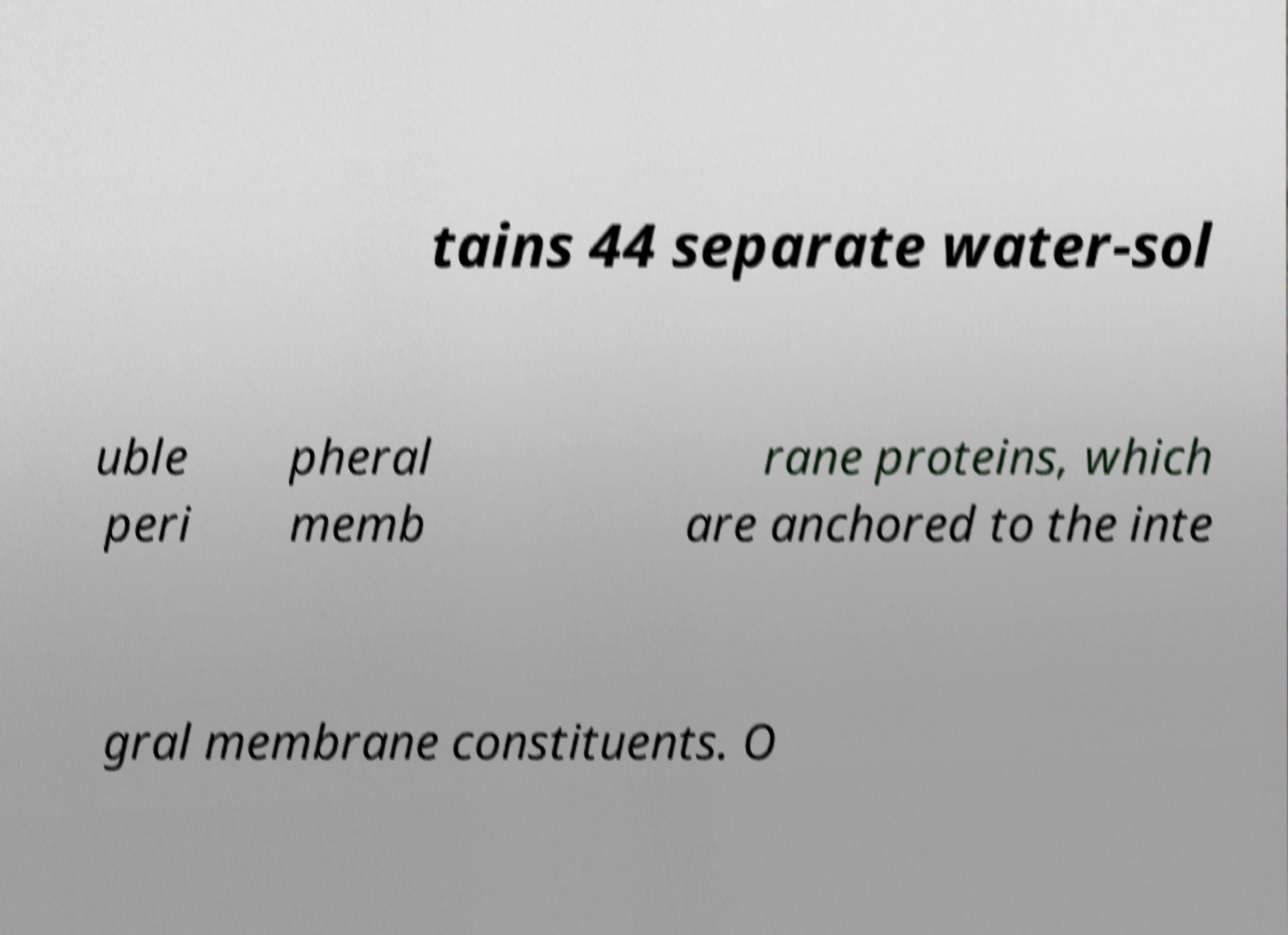Can you accurately transcribe the text from the provided image for me? tains 44 separate water-sol uble peri pheral memb rane proteins, which are anchored to the inte gral membrane constituents. O 